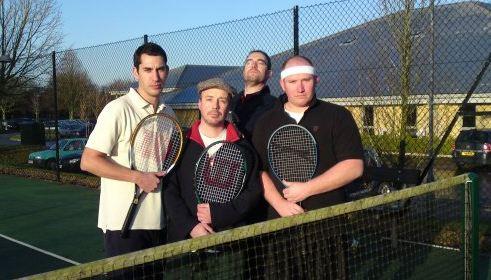What are the men holding in their hands?
Write a very short answer. Tennis racquets. What color are the men's pants?
Give a very brief answer. Black. Was the camera held parallel to the ground when this picture was taken?
Answer briefly. Yes. What is the bigger many in front wearing on his head?
Be succinct. Headband. What sport or activity are they doing?
Be succinct. Tennis. Are they on a farm?
Keep it brief. No. Are the men looking away or towards the camera?
Quick response, please. Towards. Do these people know each other?
Be succinct. Yes. What is red the man is holding in the right hand?
Be succinct. Tennis racket. 